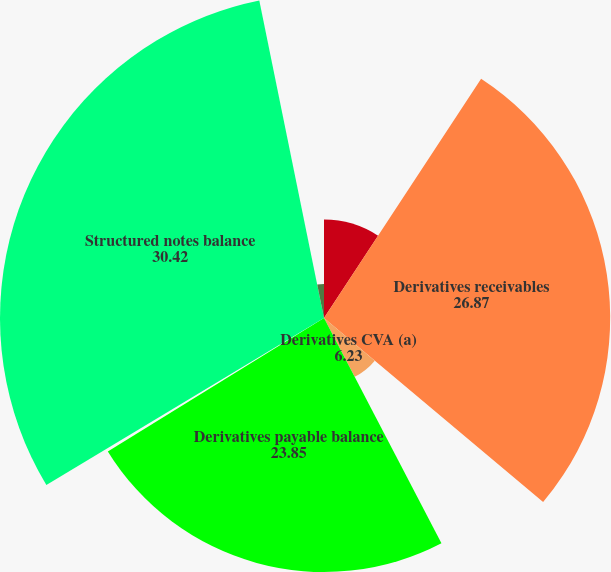<chart> <loc_0><loc_0><loc_500><loc_500><pie_chart><fcel>Year ended December 31 (in<fcel>Derivatives receivables<fcel>Derivatives CVA (a)<fcel>Derivatives payable balance<fcel>Derivatives DVA<fcel>Structured notes balance<fcel>Structured notes DVA (b)<nl><fcel>9.25%<fcel>26.87%<fcel>6.23%<fcel>23.85%<fcel>0.18%<fcel>30.42%<fcel>3.2%<nl></chart> 